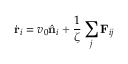<formula> <loc_0><loc_0><loc_500><loc_500>\dot { r } _ { i } = v _ { 0 } \hat { n } _ { i } + \frac { 1 } { \zeta } \sum _ { j } F _ { i j }</formula> 